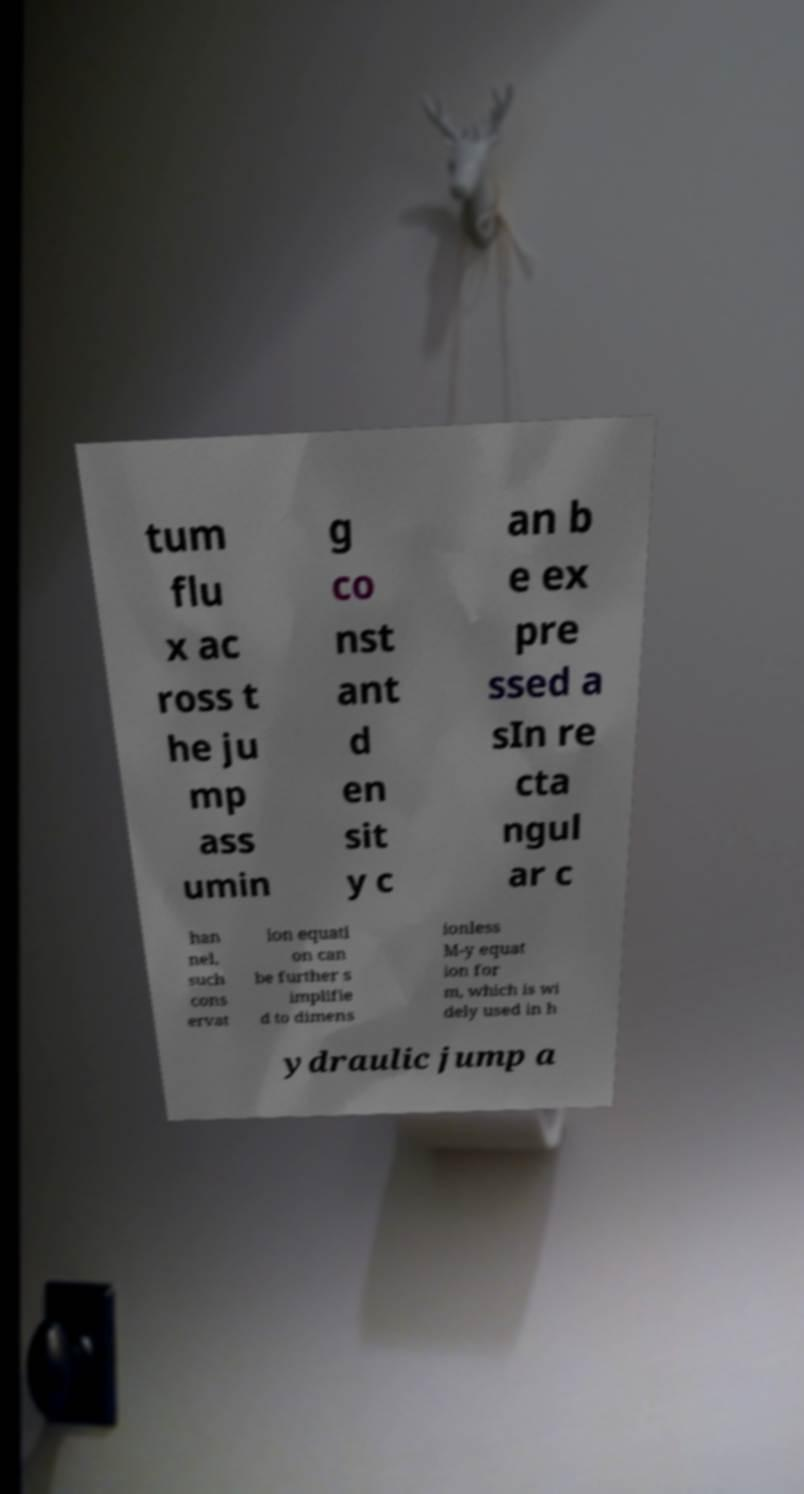Please read and relay the text visible in this image. What does it say? tum flu x ac ross t he ju mp ass umin g co nst ant d en sit y c an b e ex pre ssed a sIn re cta ngul ar c han nel, such cons ervat ion equati on can be further s implifie d to dimens ionless M-y equat ion for m, which is wi dely used in h ydraulic jump a 